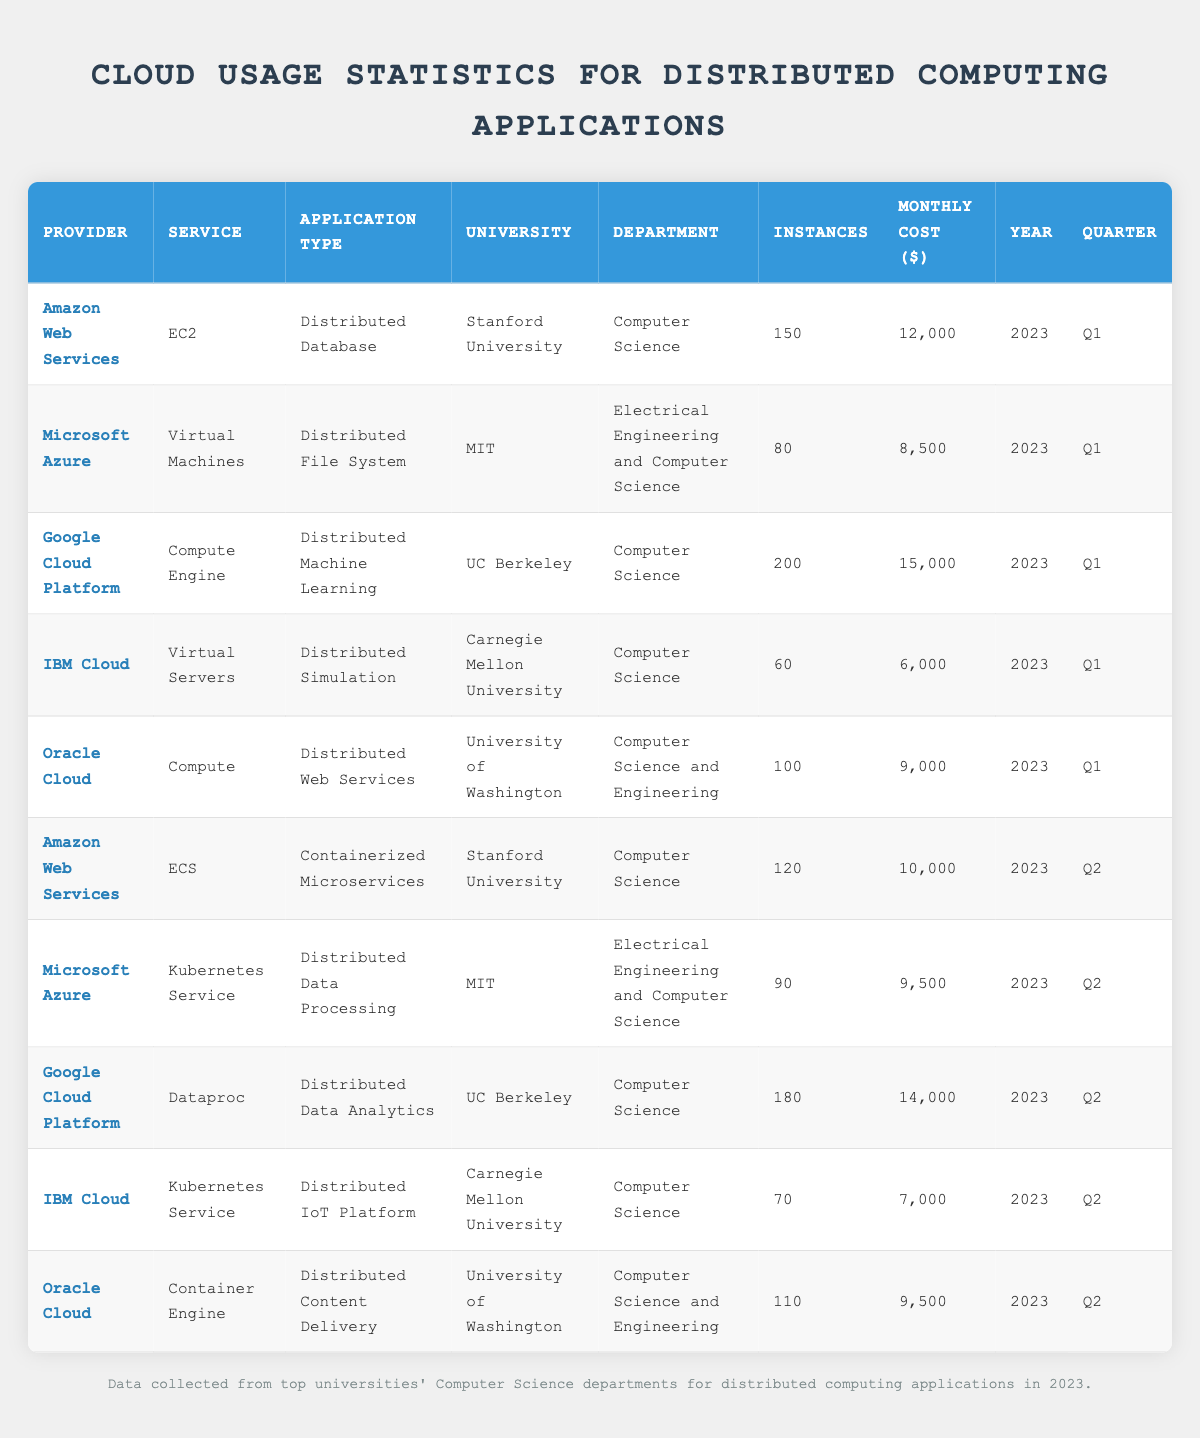What is the monthly cost associated with the use of Google Cloud Platform for Distributed Machine Learning at UC Berkeley? The table indicates that UC Berkeley uses Google Cloud Platform's Compute Engine for Distributed Machine Learning, which has a monthly cost of 15000.
Answer: 15000 Which university has the highest number of instances used in Q1 2023, and what is that number? In the Q1 2023 section of the table, we see that UC Berkeley (Google Cloud Platform) has 200 instances, which is the highest compared to other universities in that quarter.
Answer: UC Berkeley, 200 What is the total monthly cost for all cloud services used by MIT across Q1 and Q2 of 2023? For MIT in Q1, the monthly cost is 8500 with Virtual Machines and in Q2, it is 9500 with Kubernetes Service. The total is 8500 + 9500 = 18000.
Answer: 18000 Did any university use IBM Cloud services in Q2 2023? Yes, Carnegie Mellon University used IBM Cloud's Kubernetes Service in Q2 2023.
Answer: Yes What is the average monthly cost of all the services utilized by Oracle Cloud for the two quarters provided in the data? In Q1, Oracle Cloud has a cost of 9000, and in Q2, the cost is 9500. The average cost is calculated as (9000 + 9500) / 2 = 9250.
Answer: 9250 Which cloud service provider did Stanford University use in Q2 2023, and what was the monthly cost? In Q2 2023, Stanford University used Amazon Web Services' ECS service at a monthly cost of 10000.
Answer: Amazon Web Services, 10000 How many instances were utilized by Google Cloud Platform for Distributed Data Analytics at UC Berkeley in Q2 2023? The table shows that UC Berkeley used 180 instances for Google Cloud Platform's Dataproc service for Distributed Data Analytics in Q2 2023.
Answer: 180 Is it true that Oracle Cloud was used for Distributed Web Services in Q1 2023? Yes, the table confirms that Oracle Cloud was used for Distributed Web Services by the University of Washington in Q1 2023.
Answer: Yes 